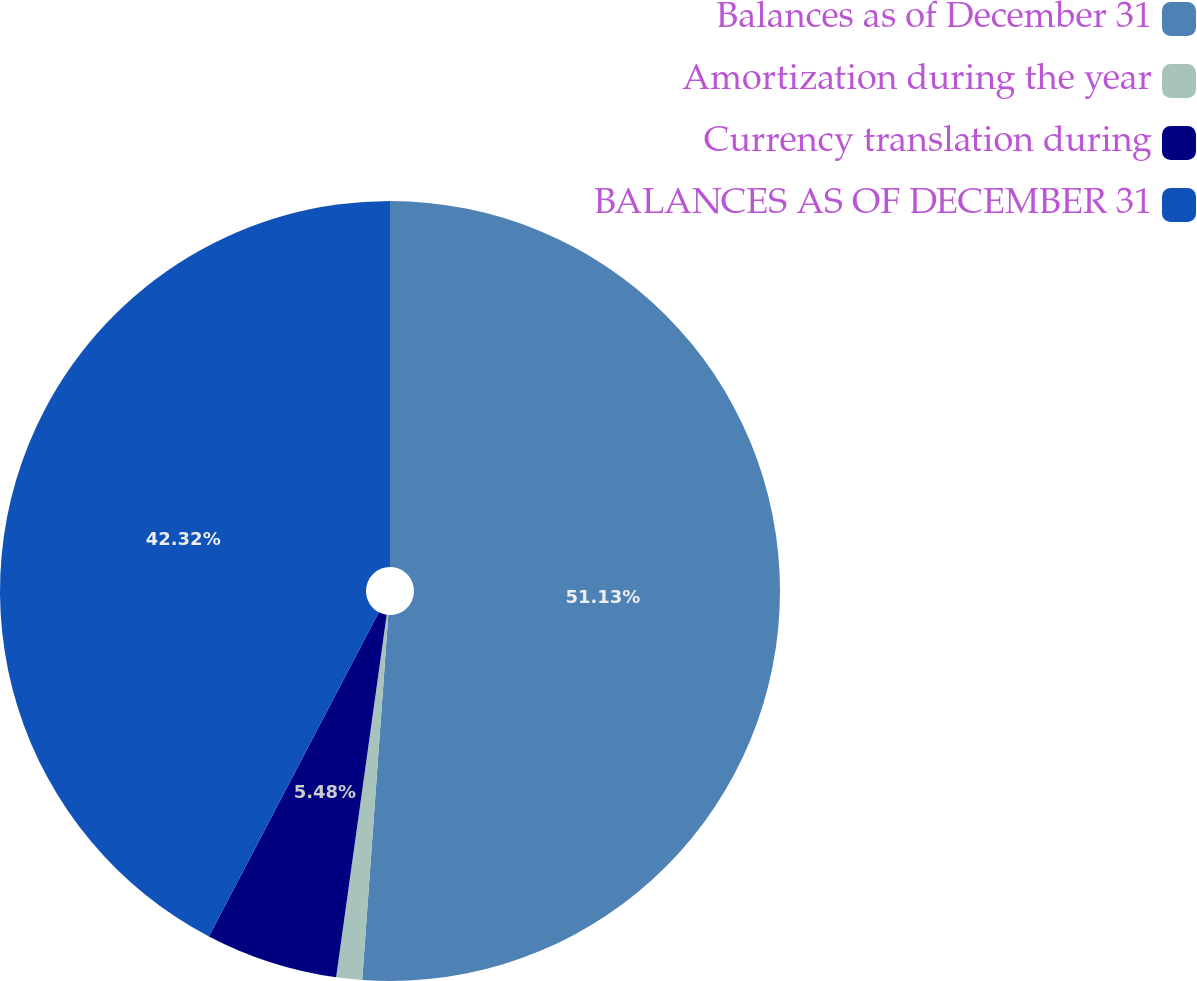Convert chart to OTSL. <chart><loc_0><loc_0><loc_500><loc_500><pie_chart><fcel>Balances as of December 31<fcel>Amortization during the year<fcel>Currency translation during<fcel>BALANCES AS OF DECEMBER 31<nl><fcel>51.14%<fcel>1.07%<fcel>5.48%<fcel>42.32%<nl></chart> 